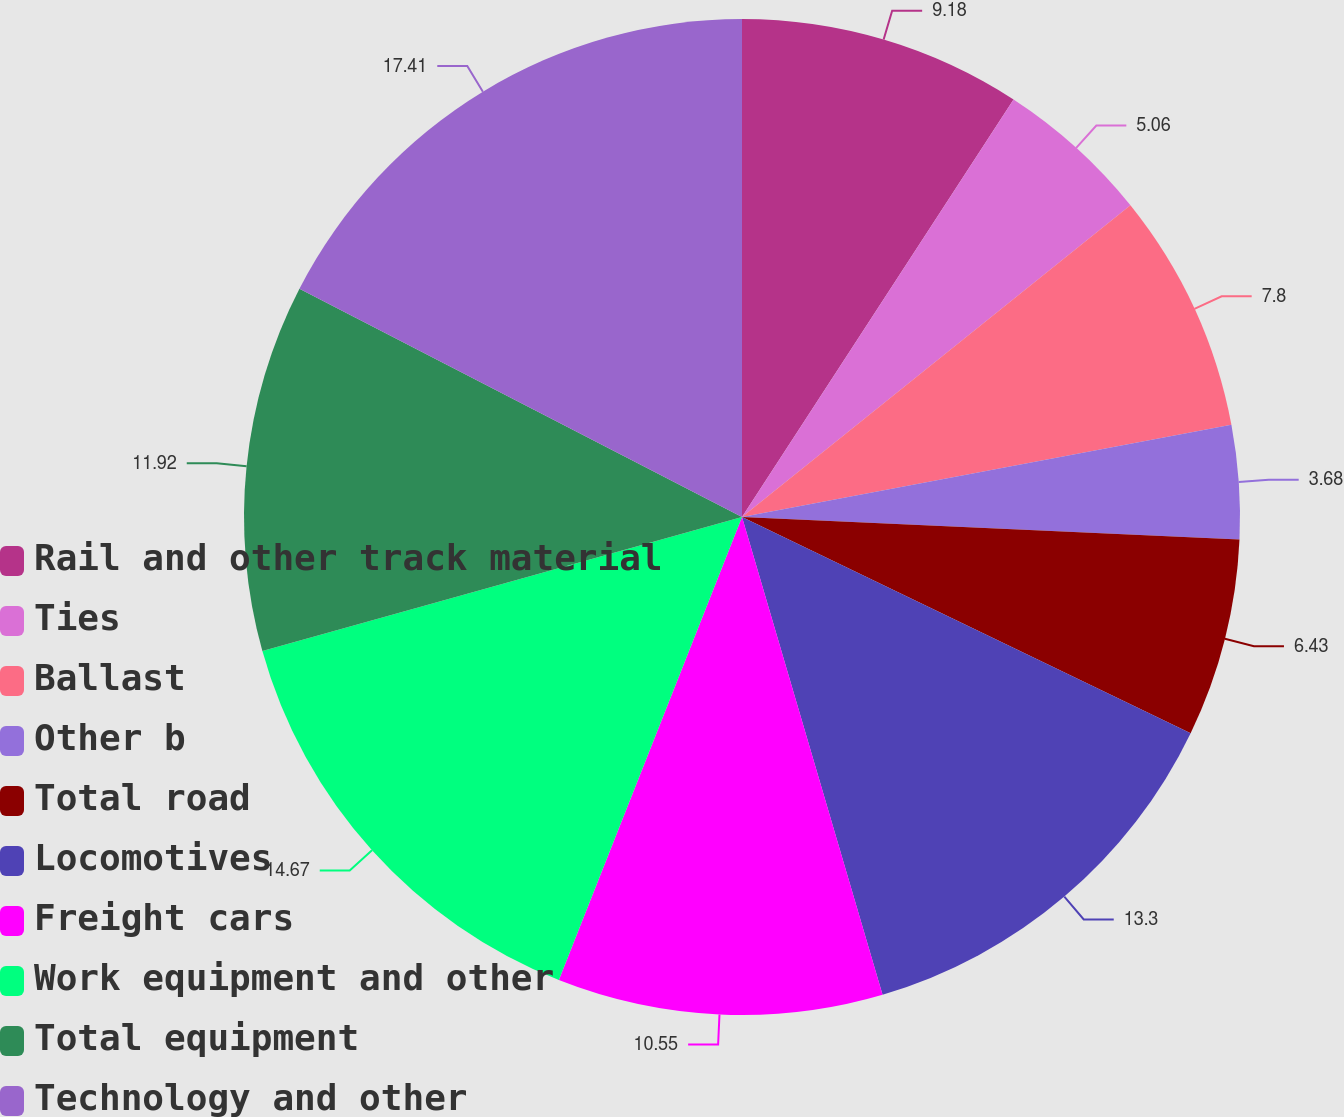<chart> <loc_0><loc_0><loc_500><loc_500><pie_chart><fcel>Rail and other track material<fcel>Ties<fcel>Ballast<fcel>Other b<fcel>Total road<fcel>Locomotives<fcel>Freight cars<fcel>Work equipment and other<fcel>Total equipment<fcel>Technology and other<nl><fcel>9.18%<fcel>5.06%<fcel>7.8%<fcel>3.68%<fcel>6.43%<fcel>13.3%<fcel>10.55%<fcel>14.67%<fcel>11.92%<fcel>17.42%<nl></chart> 